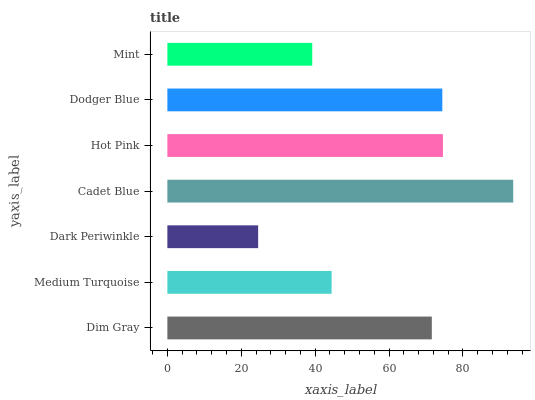Is Dark Periwinkle the minimum?
Answer yes or no. Yes. Is Cadet Blue the maximum?
Answer yes or no. Yes. Is Medium Turquoise the minimum?
Answer yes or no. No. Is Medium Turquoise the maximum?
Answer yes or no. No. Is Dim Gray greater than Medium Turquoise?
Answer yes or no. Yes. Is Medium Turquoise less than Dim Gray?
Answer yes or no. Yes. Is Medium Turquoise greater than Dim Gray?
Answer yes or no. No. Is Dim Gray less than Medium Turquoise?
Answer yes or no. No. Is Dim Gray the high median?
Answer yes or no. Yes. Is Dim Gray the low median?
Answer yes or no. Yes. Is Mint the high median?
Answer yes or no. No. Is Cadet Blue the low median?
Answer yes or no. No. 